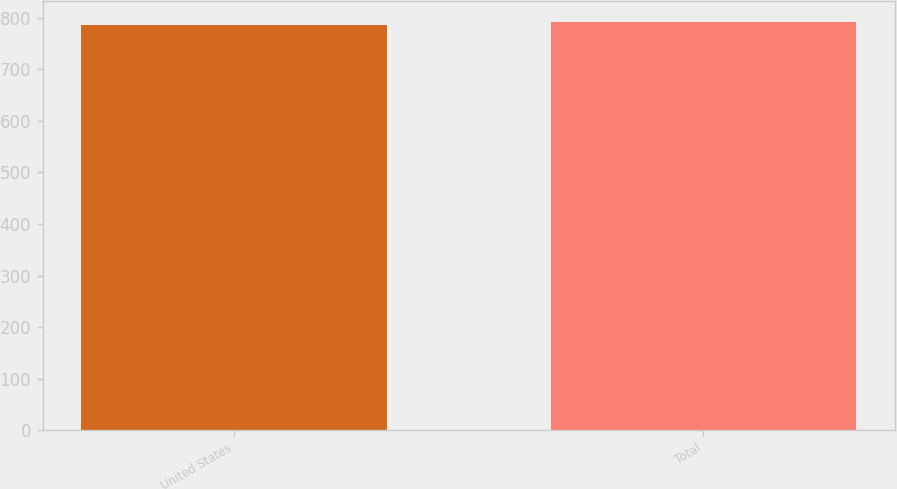Convert chart. <chart><loc_0><loc_0><loc_500><loc_500><bar_chart><fcel>United States<fcel>Total<nl><fcel>785.2<fcel>792.3<nl></chart> 